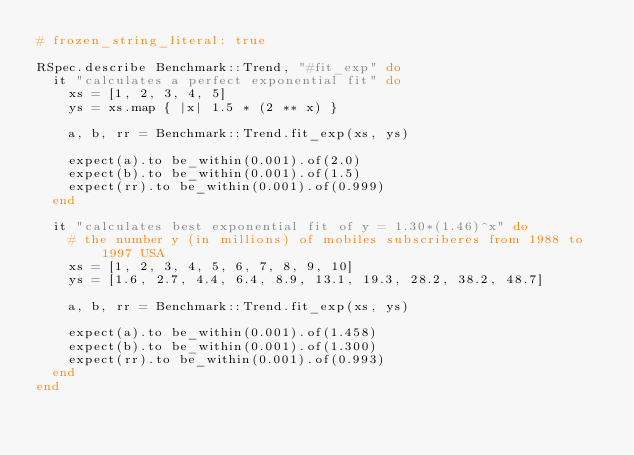Convert code to text. <code><loc_0><loc_0><loc_500><loc_500><_Ruby_># frozen_string_literal: true

RSpec.describe Benchmark::Trend, "#fit_exp" do
  it "calculates a perfect exponential fit" do
    xs = [1, 2, 3, 4, 5]
    ys = xs.map { |x| 1.5 * (2 ** x) }

    a, b, rr = Benchmark::Trend.fit_exp(xs, ys)

    expect(a).to be_within(0.001).of(2.0)
    expect(b).to be_within(0.001).of(1.5)
    expect(rr).to be_within(0.001).of(0.999)
  end

  it "calculates best exponential fit of y = 1.30*(1.46)^x" do
    # the number y (in millions) of mobiles subscriberes from 1988 to 1997 USA
    xs = [1, 2, 3, 4, 5, 6, 7, 8, 9, 10]
    ys = [1.6, 2.7, 4.4, 6.4, 8.9, 13.1, 19.3, 28.2, 38.2, 48.7]

    a, b, rr = Benchmark::Trend.fit_exp(xs, ys)

    expect(a).to be_within(0.001).of(1.458)
    expect(b).to be_within(0.001).of(1.300)
    expect(rr).to be_within(0.001).of(0.993)
  end
end
</code> 